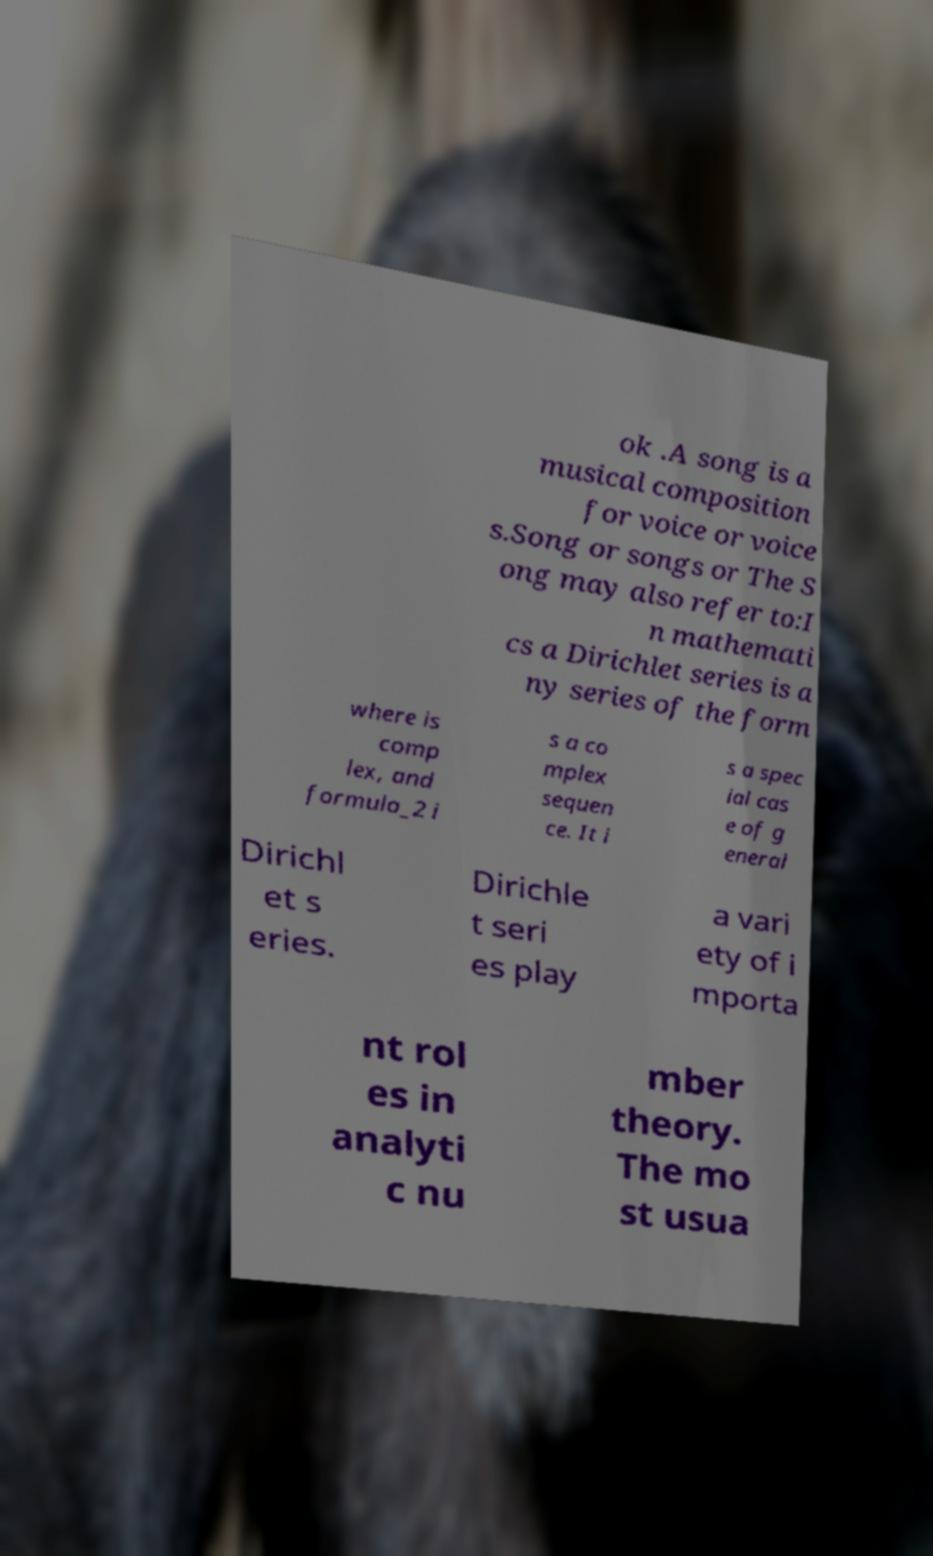What messages or text are displayed in this image? I need them in a readable, typed format. ok .A song is a musical composition for voice or voice s.Song or songs or The S ong may also refer to:I n mathemati cs a Dirichlet series is a ny series of the form where is comp lex, and formula_2 i s a co mplex sequen ce. It i s a spec ial cas e of g eneral Dirichl et s eries. Dirichle t seri es play a vari ety of i mporta nt rol es in analyti c nu mber theory. The mo st usua 